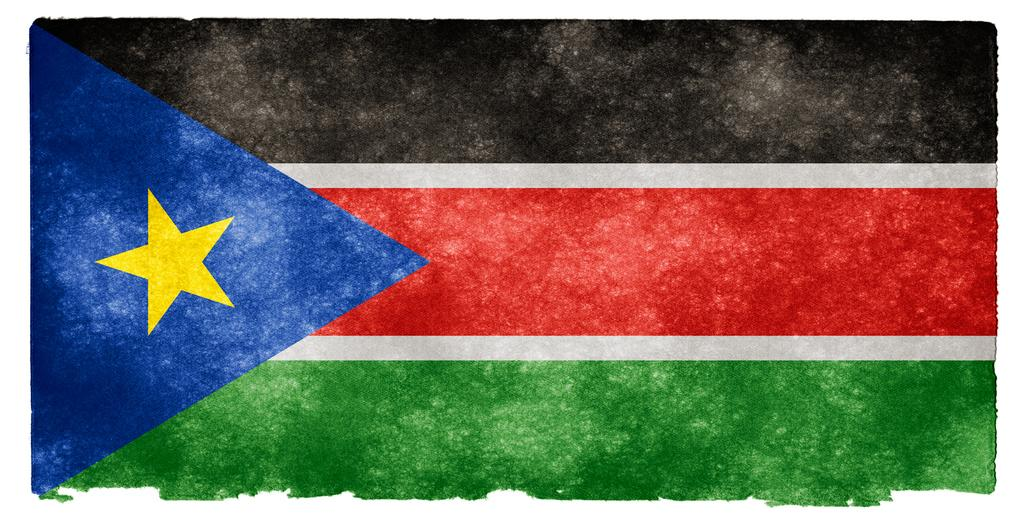What is the main subject of the image? The main subject of the image is a picture of a flag. Can you tell me how many frogs are participating in the competition shown in the image? There are no frogs or competitions present in the image; it features a picture of a flag. What type of railway is visible in the image? There is no railway present in the image; it features a picture of a flag. 